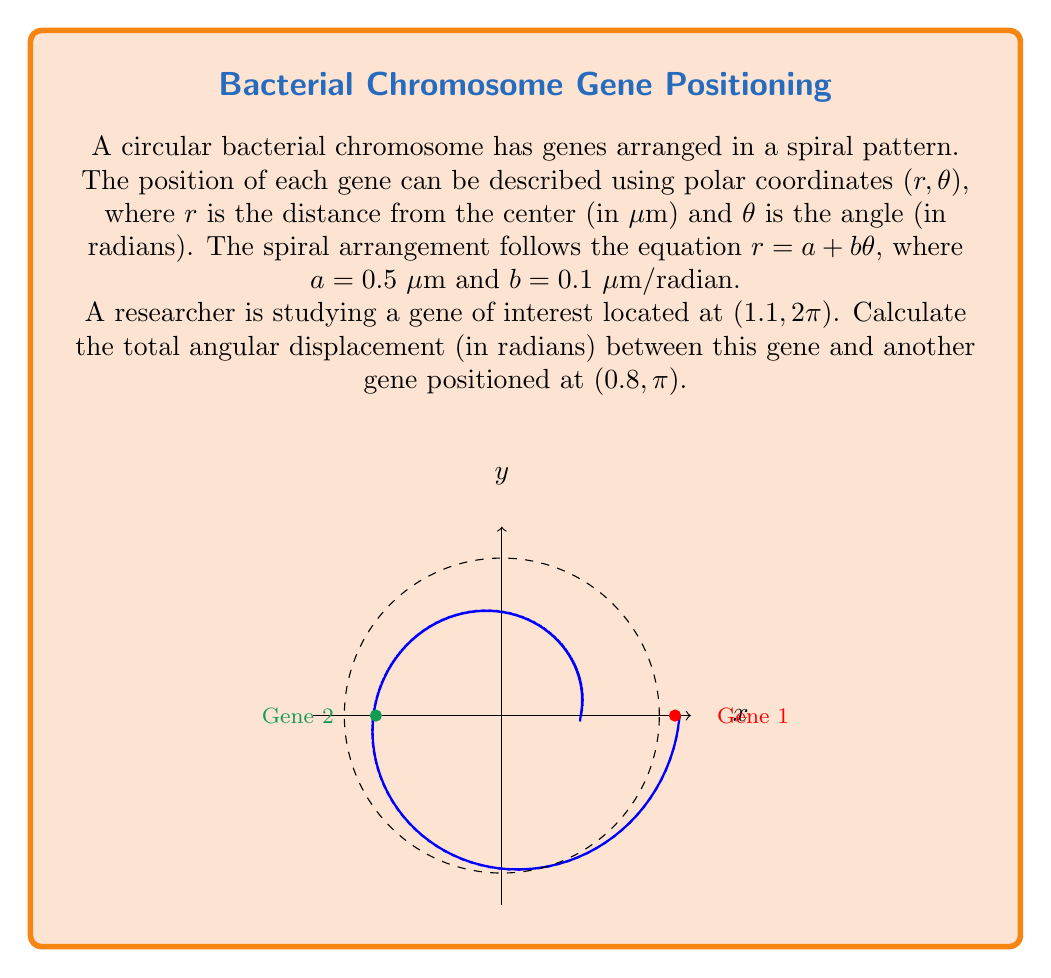Give your solution to this math problem. To solve this problem, we need to follow these steps:

1) First, let's identify the angular positions of both genes:
   - Gene of interest: $\theta_1 = 2\pi$ radians
   - Other gene: $\theta_2 = \pi$ radians

2) The angular displacement is the absolute difference between these angles:
   $$|\theta_1 - \theta_2| = |2\pi - \pi| = \pi$$

3) However, this is not necessarily the shortest angular distance on a circle. The shortest angular distance is always the smaller of two possible arcs: the one we calculated and $2\pi$ minus that arc.

4) Therefore, the total angular displacement is:
   $$\min(\pi, 2\pi - \pi) = \min(\pi, \pi) = \pi$$

5) This result makes sense geometrically, as $\pi$ radians represents half a circle, which is the shortest angular distance between two points on opposite sides of a circle.

This calculation is crucial for understanding the relative positions of genes on the bacterial chromosome, which can have implications for gene regulation and expression patterns.
Answer: $\pi$ radians 